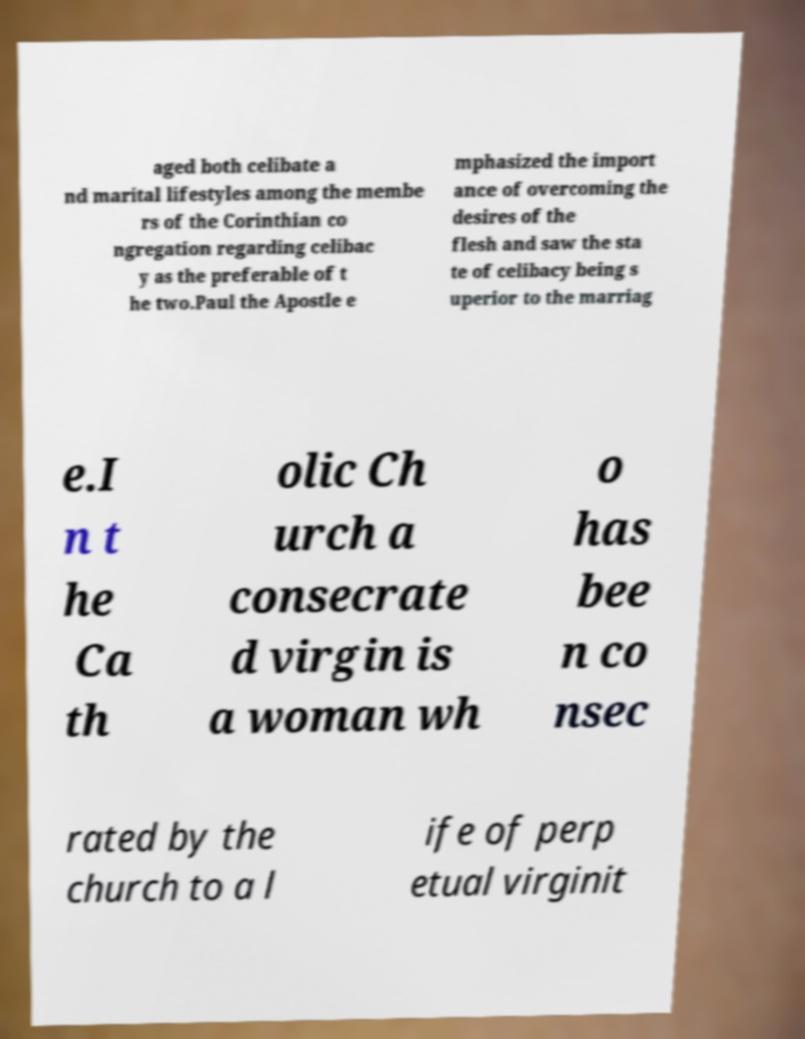What messages or text are displayed in this image? I need them in a readable, typed format. aged both celibate a nd marital lifestyles among the membe rs of the Corinthian co ngregation regarding celibac y as the preferable of t he two.Paul the Apostle e mphasized the import ance of overcoming the desires of the flesh and saw the sta te of celibacy being s uperior to the marriag e.I n t he Ca th olic Ch urch a consecrate d virgin is a woman wh o has bee n co nsec rated by the church to a l ife of perp etual virginit 